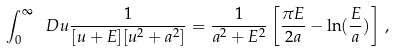<formula> <loc_0><loc_0><loc_500><loc_500>\int _ { 0 } ^ { \infty } \ D u \frac { 1 } { [ u + E ] [ u ^ { 2 } + a ^ { 2 } ] } = \frac { 1 } { a ^ { 2 } + E ^ { 2 } } \left [ \frac { \pi E } { 2 a } - \ln ( \frac { E } { a } ) \right ] \, ,</formula> 